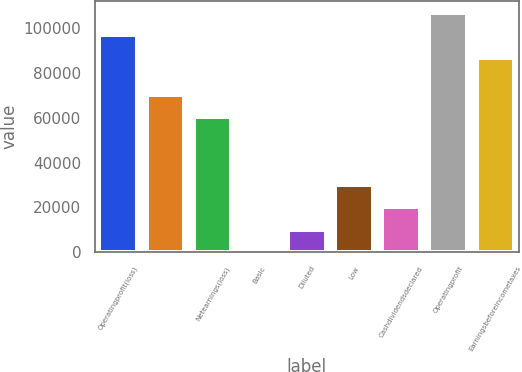Convert chart. <chart><loc_0><loc_0><loc_500><loc_500><bar_chart><fcel>Operatingprofit(loss)<fcel>Unnamed: 1<fcel>Netearnings(loss)<fcel>Basic<fcel>Diluted<fcel>Low<fcel>Cashdividendsdeclared<fcel>Operatingprofit<fcel>Earningsbeforeincometaxes<nl><fcel>96884.4<fcel>70297.4<fcel>60299<fcel>0.48<fcel>9998.83<fcel>29995.5<fcel>19997.2<fcel>106883<fcel>86886<nl></chart> 